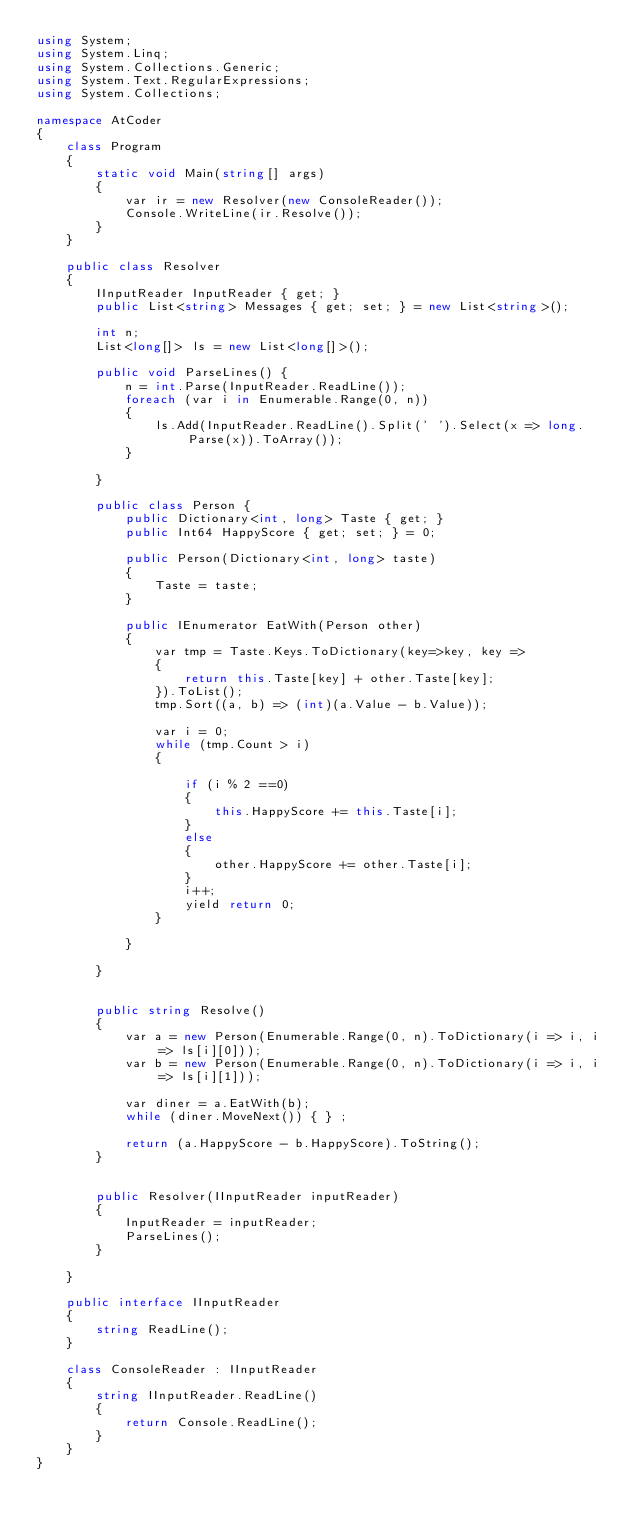Convert code to text. <code><loc_0><loc_0><loc_500><loc_500><_C#_>using System;
using System.Linq;
using System.Collections.Generic;
using System.Text.RegularExpressions;
using System.Collections;

namespace AtCoder
{
    class Program
    {
        static void Main(string[] args)
        {
            var ir = new Resolver(new ConsoleReader());
            Console.WriteLine(ir.Resolve());
        }
    }

    public class Resolver
    {
        IInputReader InputReader { get; }
        public List<string> Messages { get; set; } = new List<string>();

        int n;
        List<long[]> ls = new List<long[]>();

        public void ParseLines() {
            n = int.Parse(InputReader.ReadLine());
            foreach (var i in Enumerable.Range(0, n))
            {
                ls.Add(InputReader.ReadLine().Split(' ').Select(x => long.Parse(x)).ToArray());
            }

        }

        public class Person {
            public Dictionary<int, long> Taste { get; }
            public Int64 HappyScore { get; set; } = 0;

            public Person(Dictionary<int, long> taste)
            {
                Taste = taste;
            }

            public IEnumerator EatWith(Person other)
            {
                var tmp = Taste.Keys.ToDictionary(key=>key, key =>
                {
                    return this.Taste[key] + other.Taste[key];
                }).ToList();
                tmp.Sort((a, b) => (int)(a.Value - b.Value));

                var i = 0;
                while (tmp.Count > i)
                {

                    if (i % 2 ==0)
                    {
                        this.HappyScore += this.Taste[i];
                    }
                    else
                    {
                        other.HappyScore += other.Taste[i];
                    }
                    i++;
                    yield return 0;
                }

            }

        }


        public string Resolve()
        {
            var a = new Person(Enumerable.Range(0, n).ToDictionary(i => i, i => ls[i][0]));
            var b = new Person(Enumerable.Range(0, n).ToDictionary(i => i, i => ls[i][1]));

            var diner = a.EatWith(b);
            while (diner.MoveNext()) { } ;

            return (a.HappyScore - b.HappyScore).ToString();
        }


        public Resolver(IInputReader inputReader)
        {
            InputReader = inputReader;
            ParseLines();
        }

    }

    public interface IInputReader
    {
        string ReadLine();
    }

    class ConsoleReader : IInputReader
    {
        string IInputReader.ReadLine()
        {
            return Console.ReadLine();
        }
    }
}
</code> 